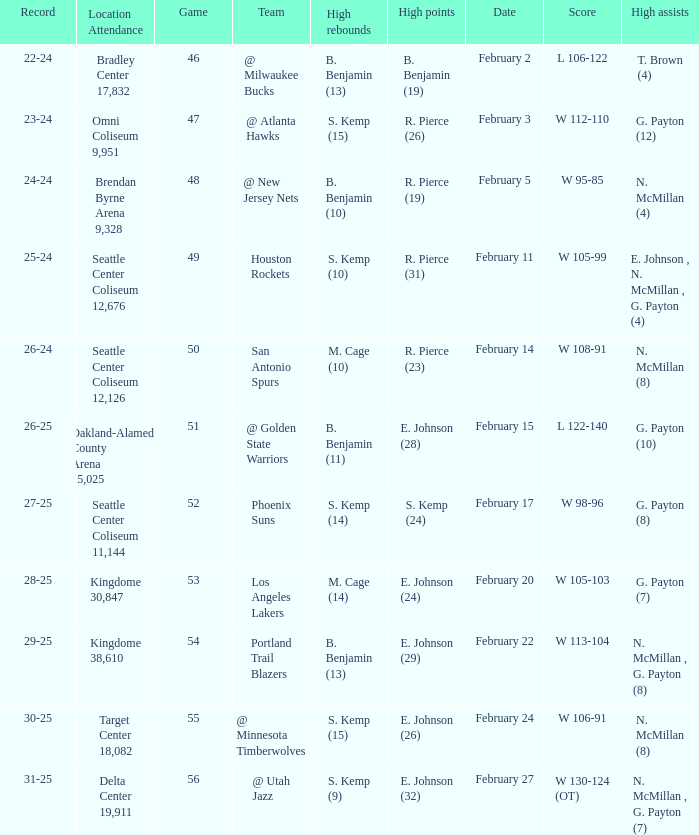What dated was the game played at the location delta center 19,911? February 27. 